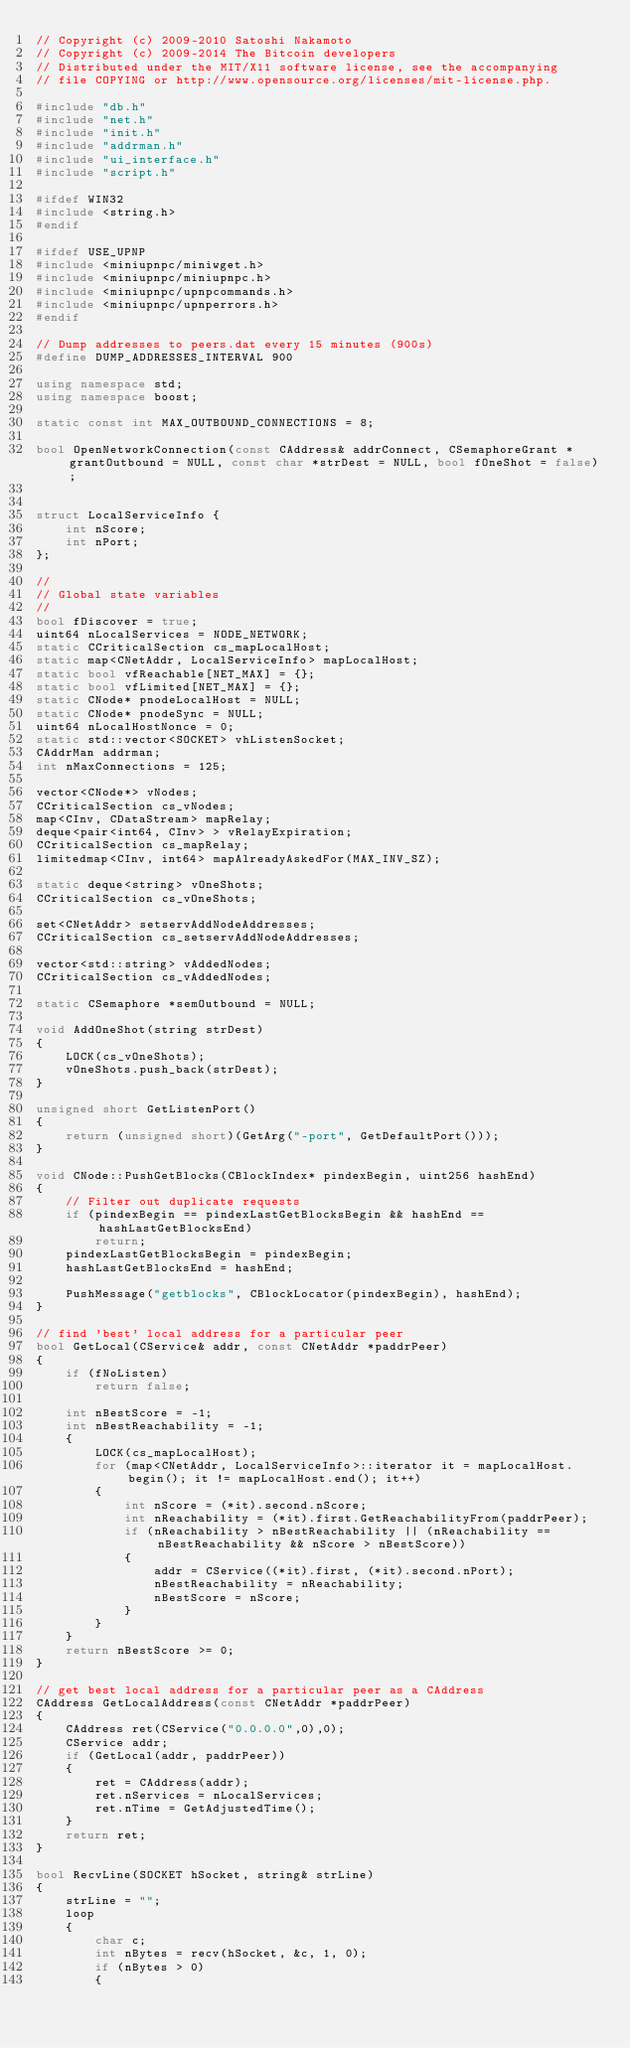Convert code to text. <code><loc_0><loc_0><loc_500><loc_500><_C++_>// Copyright (c) 2009-2010 Satoshi Nakamoto
// Copyright (c) 2009-2014 The Bitcoin developers
// Distributed under the MIT/X11 software license, see the accompanying
// file COPYING or http://www.opensource.org/licenses/mit-license.php.

#include "db.h"
#include "net.h"
#include "init.h"
#include "addrman.h"
#include "ui_interface.h"
#include "script.h"

#ifdef WIN32
#include <string.h>
#endif

#ifdef USE_UPNP
#include <miniupnpc/miniwget.h>
#include <miniupnpc/miniupnpc.h>
#include <miniupnpc/upnpcommands.h>
#include <miniupnpc/upnperrors.h>
#endif

// Dump addresses to peers.dat every 15 minutes (900s)
#define DUMP_ADDRESSES_INTERVAL 900

using namespace std;
using namespace boost;

static const int MAX_OUTBOUND_CONNECTIONS = 8;

bool OpenNetworkConnection(const CAddress& addrConnect, CSemaphoreGrant *grantOutbound = NULL, const char *strDest = NULL, bool fOneShot = false);


struct LocalServiceInfo {
    int nScore;
    int nPort;
};

//
// Global state variables
//
bool fDiscover = true;
uint64 nLocalServices = NODE_NETWORK;
static CCriticalSection cs_mapLocalHost;
static map<CNetAddr, LocalServiceInfo> mapLocalHost;
static bool vfReachable[NET_MAX] = {};
static bool vfLimited[NET_MAX] = {};
static CNode* pnodeLocalHost = NULL;
static CNode* pnodeSync = NULL;
uint64 nLocalHostNonce = 0;
static std::vector<SOCKET> vhListenSocket;
CAddrMan addrman;
int nMaxConnections = 125;

vector<CNode*> vNodes;
CCriticalSection cs_vNodes;
map<CInv, CDataStream> mapRelay;
deque<pair<int64, CInv> > vRelayExpiration;
CCriticalSection cs_mapRelay;
limitedmap<CInv, int64> mapAlreadyAskedFor(MAX_INV_SZ);

static deque<string> vOneShots;
CCriticalSection cs_vOneShots;

set<CNetAddr> setservAddNodeAddresses;
CCriticalSection cs_setservAddNodeAddresses;

vector<std::string> vAddedNodes;
CCriticalSection cs_vAddedNodes;

static CSemaphore *semOutbound = NULL;

void AddOneShot(string strDest)
{
    LOCK(cs_vOneShots);
    vOneShots.push_back(strDest);
}

unsigned short GetListenPort()
{
    return (unsigned short)(GetArg("-port", GetDefaultPort()));
}

void CNode::PushGetBlocks(CBlockIndex* pindexBegin, uint256 hashEnd)
{
    // Filter out duplicate requests
    if (pindexBegin == pindexLastGetBlocksBegin && hashEnd == hashLastGetBlocksEnd)
        return;
    pindexLastGetBlocksBegin = pindexBegin;
    hashLastGetBlocksEnd = hashEnd;

    PushMessage("getblocks", CBlockLocator(pindexBegin), hashEnd);
}

// find 'best' local address for a particular peer
bool GetLocal(CService& addr, const CNetAddr *paddrPeer)
{
    if (fNoListen)
        return false;

    int nBestScore = -1;
    int nBestReachability = -1;
    {
        LOCK(cs_mapLocalHost);
        for (map<CNetAddr, LocalServiceInfo>::iterator it = mapLocalHost.begin(); it != mapLocalHost.end(); it++)
        {
            int nScore = (*it).second.nScore;
            int nReachability = (*it).first.GetReachabilityFrom(paddrPeer);
            if (nReachability > nBestReachability || (nReachability == nBestReachability && nScore > nBestScore))
            {
                addr = CService((*it).first, (*it).second.nPort);
                nBestReachability = nReachability;
                nBestScore = nScore;
            }
        }
    }
    return nBestScore >= 0;
}

// get best local address for a particular peer as a CAddress
CAddress GetLocalAddress(const CNetAddr *paddrPeer)
{
    CAddress ret(CService("0.0.0.0",0),0);
    CService addr;
    if (GetLocal(addr, paddrPeer))
    {
        ret = CAddress(addr);
        ret.nServices = nLocalServices;
        ret.nTime = GetAdjustedTime();
    }
    return ret;
}

bool RecvLine(SOCKET hSocket, string& strLine)
{
    strLine = "";
    loop
    {
        char c;
        int nBytes = recv(hSocket, &c, 1, 0);
        if (nBytes > 0)
        {</code> 